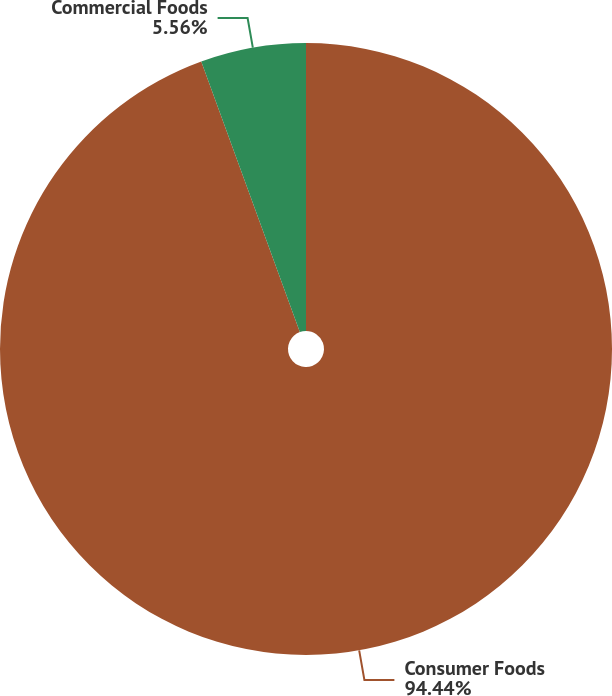Convert chart. <chart><loc_0><loc_0><loc_500><loc_500><pie_chart><fcel>Consumer Foods<fcel>Commercial Foods<nl><fcel>94.44%<fcel>5.56%<nl></chart> 